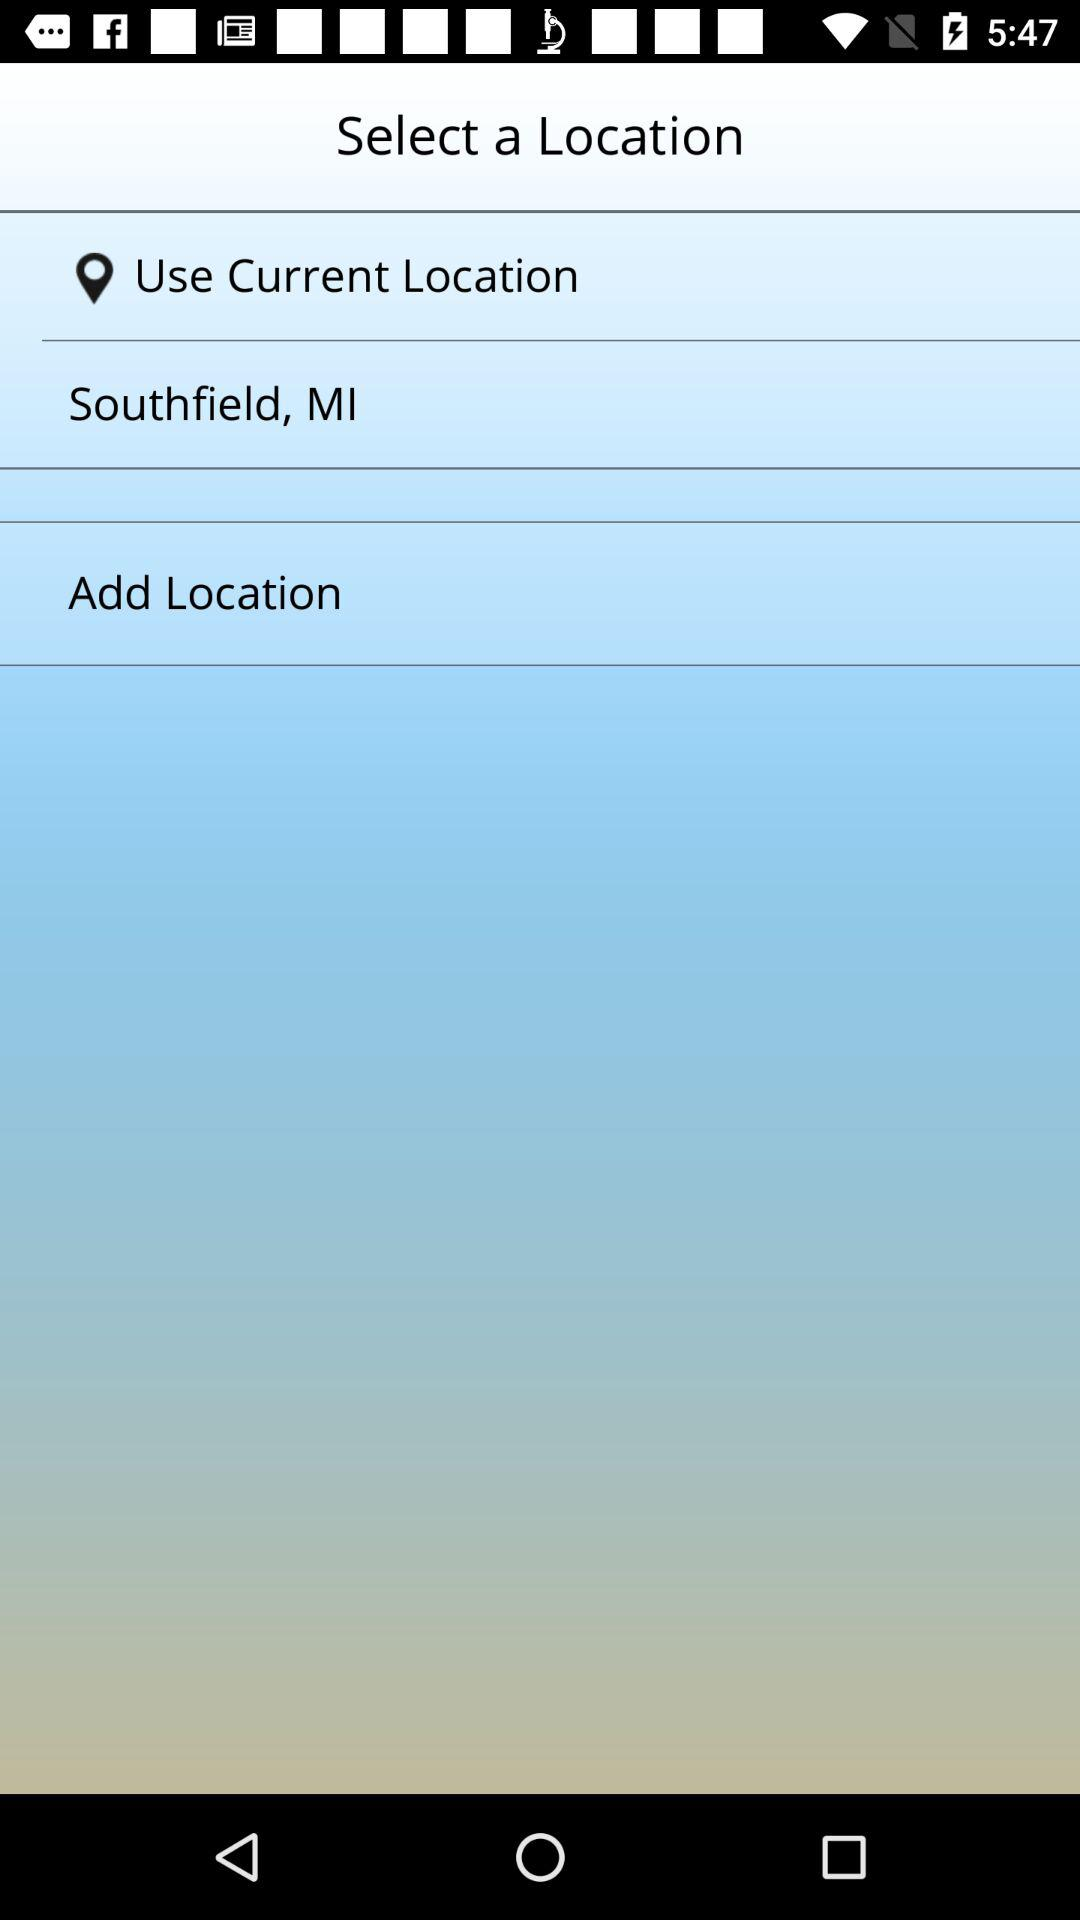How many location options are available?
Answer the question using a single word or phrase. 3 